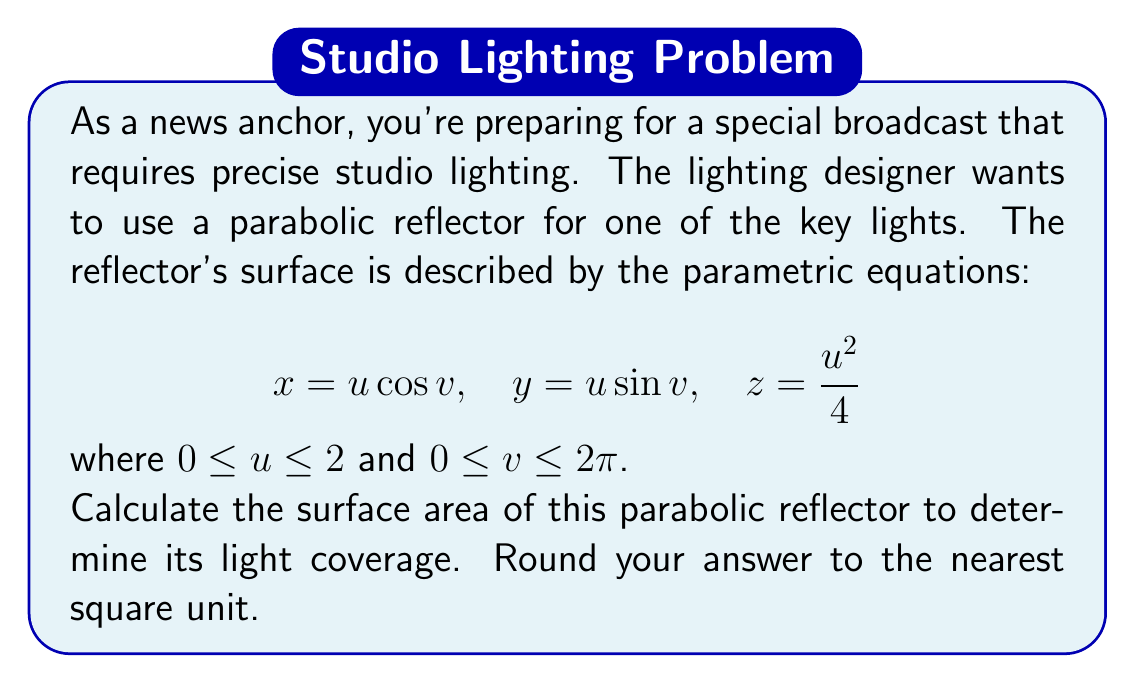Can you answer this question? To find the surface area of the parabolic reflector, we need to use the surface area formula for parametric surfaces:

$$A = \iint_D \left|\frac{\partial \mathbf{r}}{\partial u} \times \frac{\partial \mathbf{r}}{\partial v}\right| du dv$$

where $\mathbf{r}(u,v) = (x(u,v), y(u,v), z(u,v))$.

Step 1: Calculate the partial derivatives
$$\frac{\partial \mathbf{r}}{\partial u} = (\cos v, \sin v, \frac{u}{2})$$
$$\frac{\partial \mathbf{r}}{\partial v} = (-u\sin v, u\cos v, 0)$$

Step 2: Calculate the cross product
$$\frac{\partial \mathbf{r}}{\partial u} \times \frac{\partial \mathbf{r}}{\partial v} = (u\cos v, u\sin v, -u)$$

Step 3: Calculate the magnitude of the cross product
$$\left|\frac{\partial \mathbf{r}}{\partial u} \times \frac{\partial \mathbf{r}}{\partial v}\right| = \sqrt{u^2\cos^2 v + u^2\sin^2 v + u^2} = u\sqrt{2}$$

Step 4: Set up the double integral
$$A = \int_0^{2\pi} \int_0^2 u\sqrt{2} \, du \, dv$$

Step 5: Evaluate the integral
$$A = \sqrt{2} \int_0^{2\pi} \left[\frac{u^2}{2}\right]_0^2 dv = 2\sqrt{2} \int_0^{2\pi} dv = 4\sqrt{2}\pi$$

Step 6: Calculate the final result and round to the nearest square unit
$$A \approx 17.77 \text{ square units}$$

Rounding to the nearest square unit, we get 18 square units.
Answer: 18 square units 